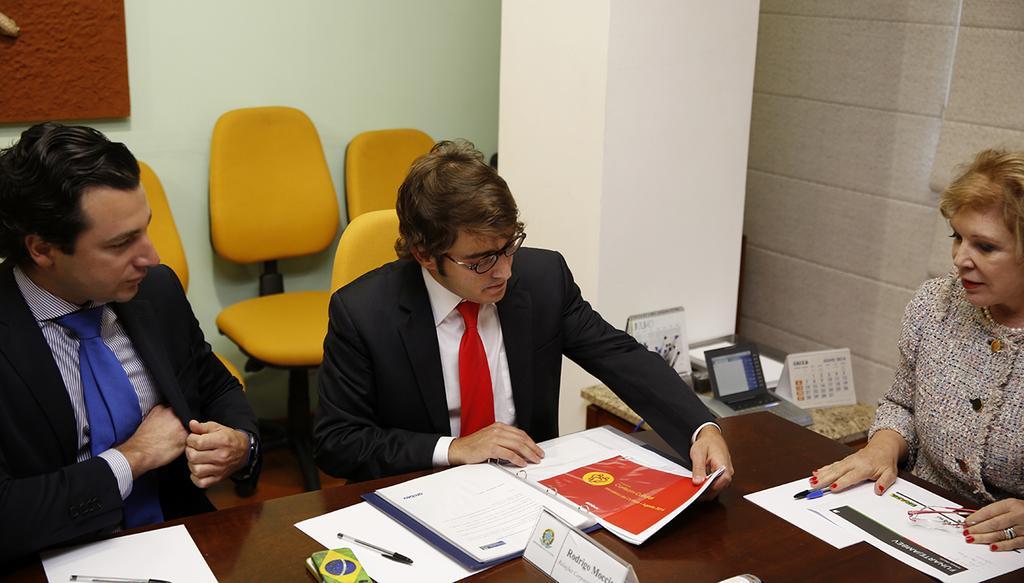How would you summarize this image in a sentence or two? At the bottom of the image on the table there are papers, pens and some other things. Behind the table there are two men and one lady. There is a man with spectacles. Behind them there is a table with calendars, telephone and some other things. And also there are chairs and also there is a pillar. In the top left corner of the image there is an object on the wall. 